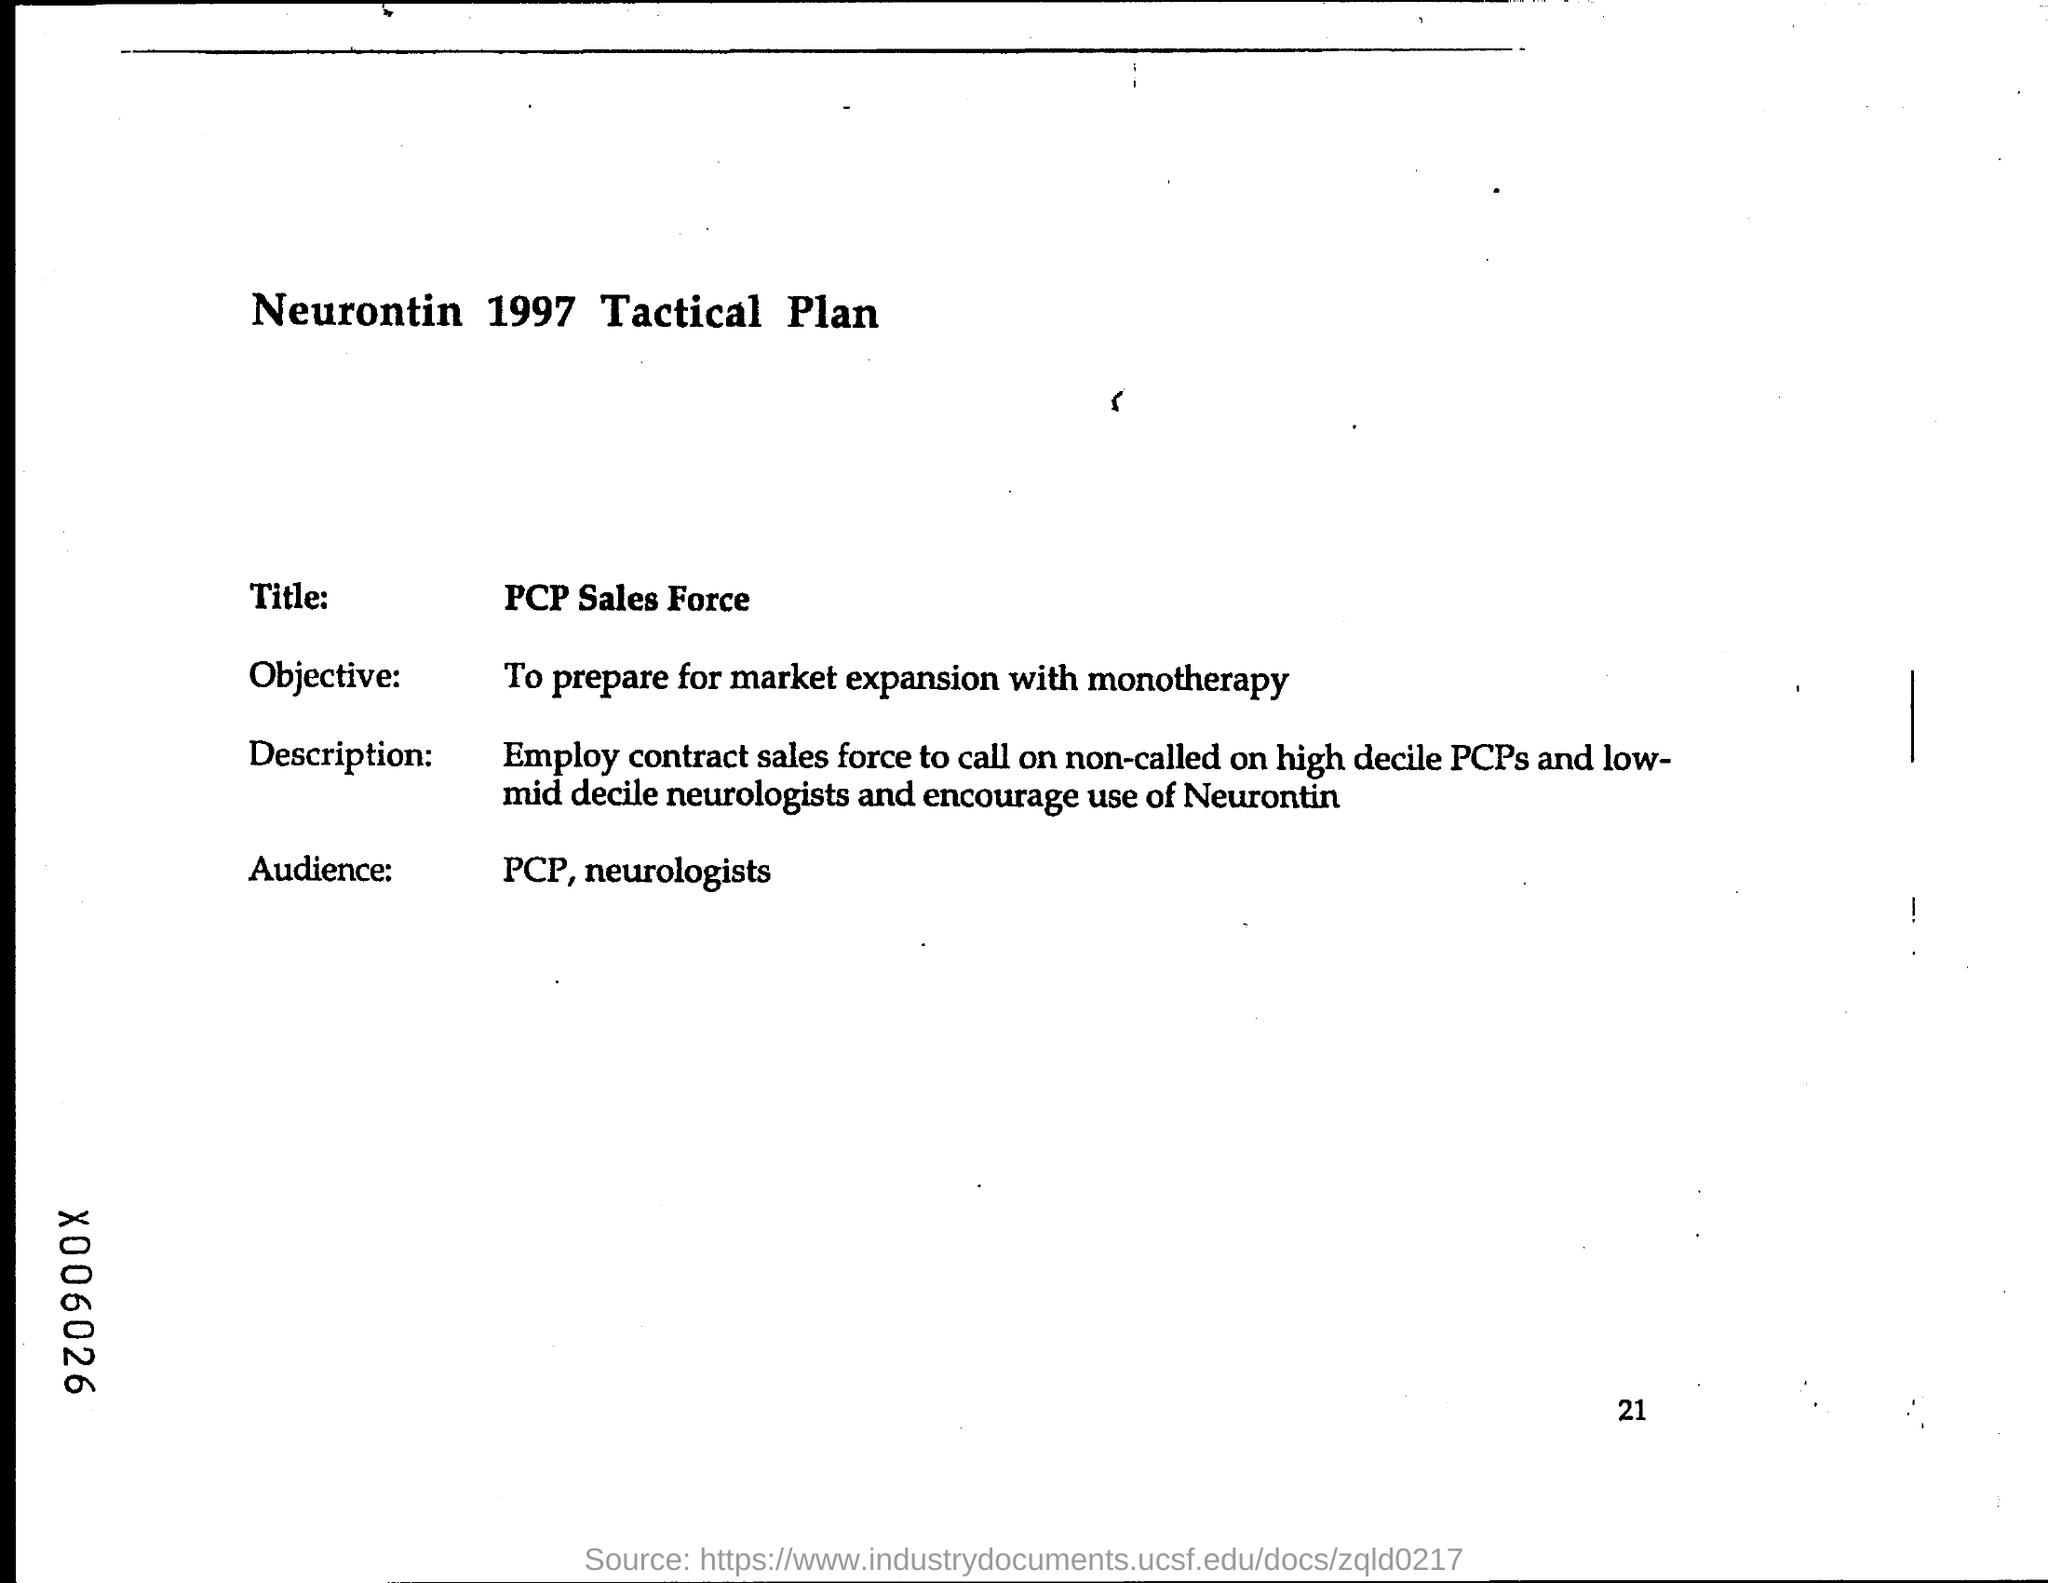Draw attention to some important aspects in this diagram. The page number at the bottom of the page is 21. The intended audience for this presentation are primary care physicians and neurologists. The title of this document is related to PCP sales force. 